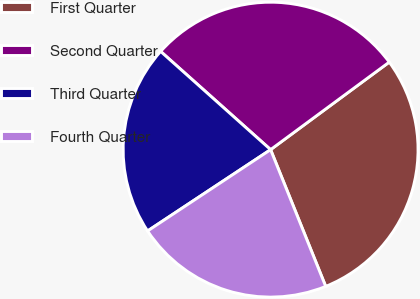Convert chart. <chart><loc_0><loc_0><loc_500><loc_500><pie_chart><fcel>First Quarter<fcel>Second Quarter<fcel>Third Quarter<fcel>Fourth Quarter<nl><fcel>29.02%<fcel>28.28%<fcel>20.9%<fcel>21.8%<nl></chart> 